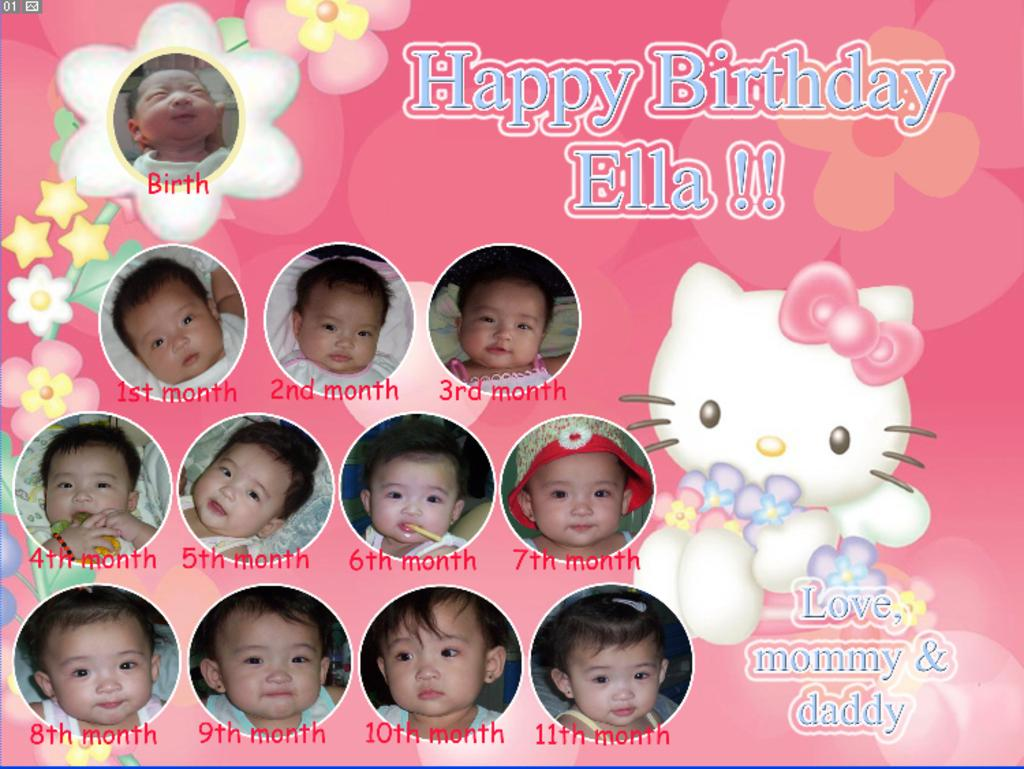What type of pictures are in the image? The image contains baby pictures. What else can be found in the image besides the baby pictures? There is text present in the image. Where is the airport located in the image? There is no airport present in the image; it contains baby pictures and text. What type of fang can be seen in the image? There is no fang present in the image. 